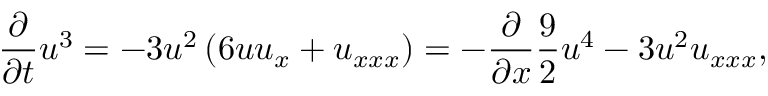Convert formula to latex. <formula><loc_0><loc_0><loc_500><loc_500>\frac { \partial } { \partial t } u ^ { 3 } = - 3 u ^ { 2 } \left ( 6 u u _ { x } + u _ { x x x } \right ) = - \frac { \partial } { \partial x } \frac { 9 } { 2 } u ^ { 4 } - 3 u ^ { 2 } u _ { x x x } ,</formula> 